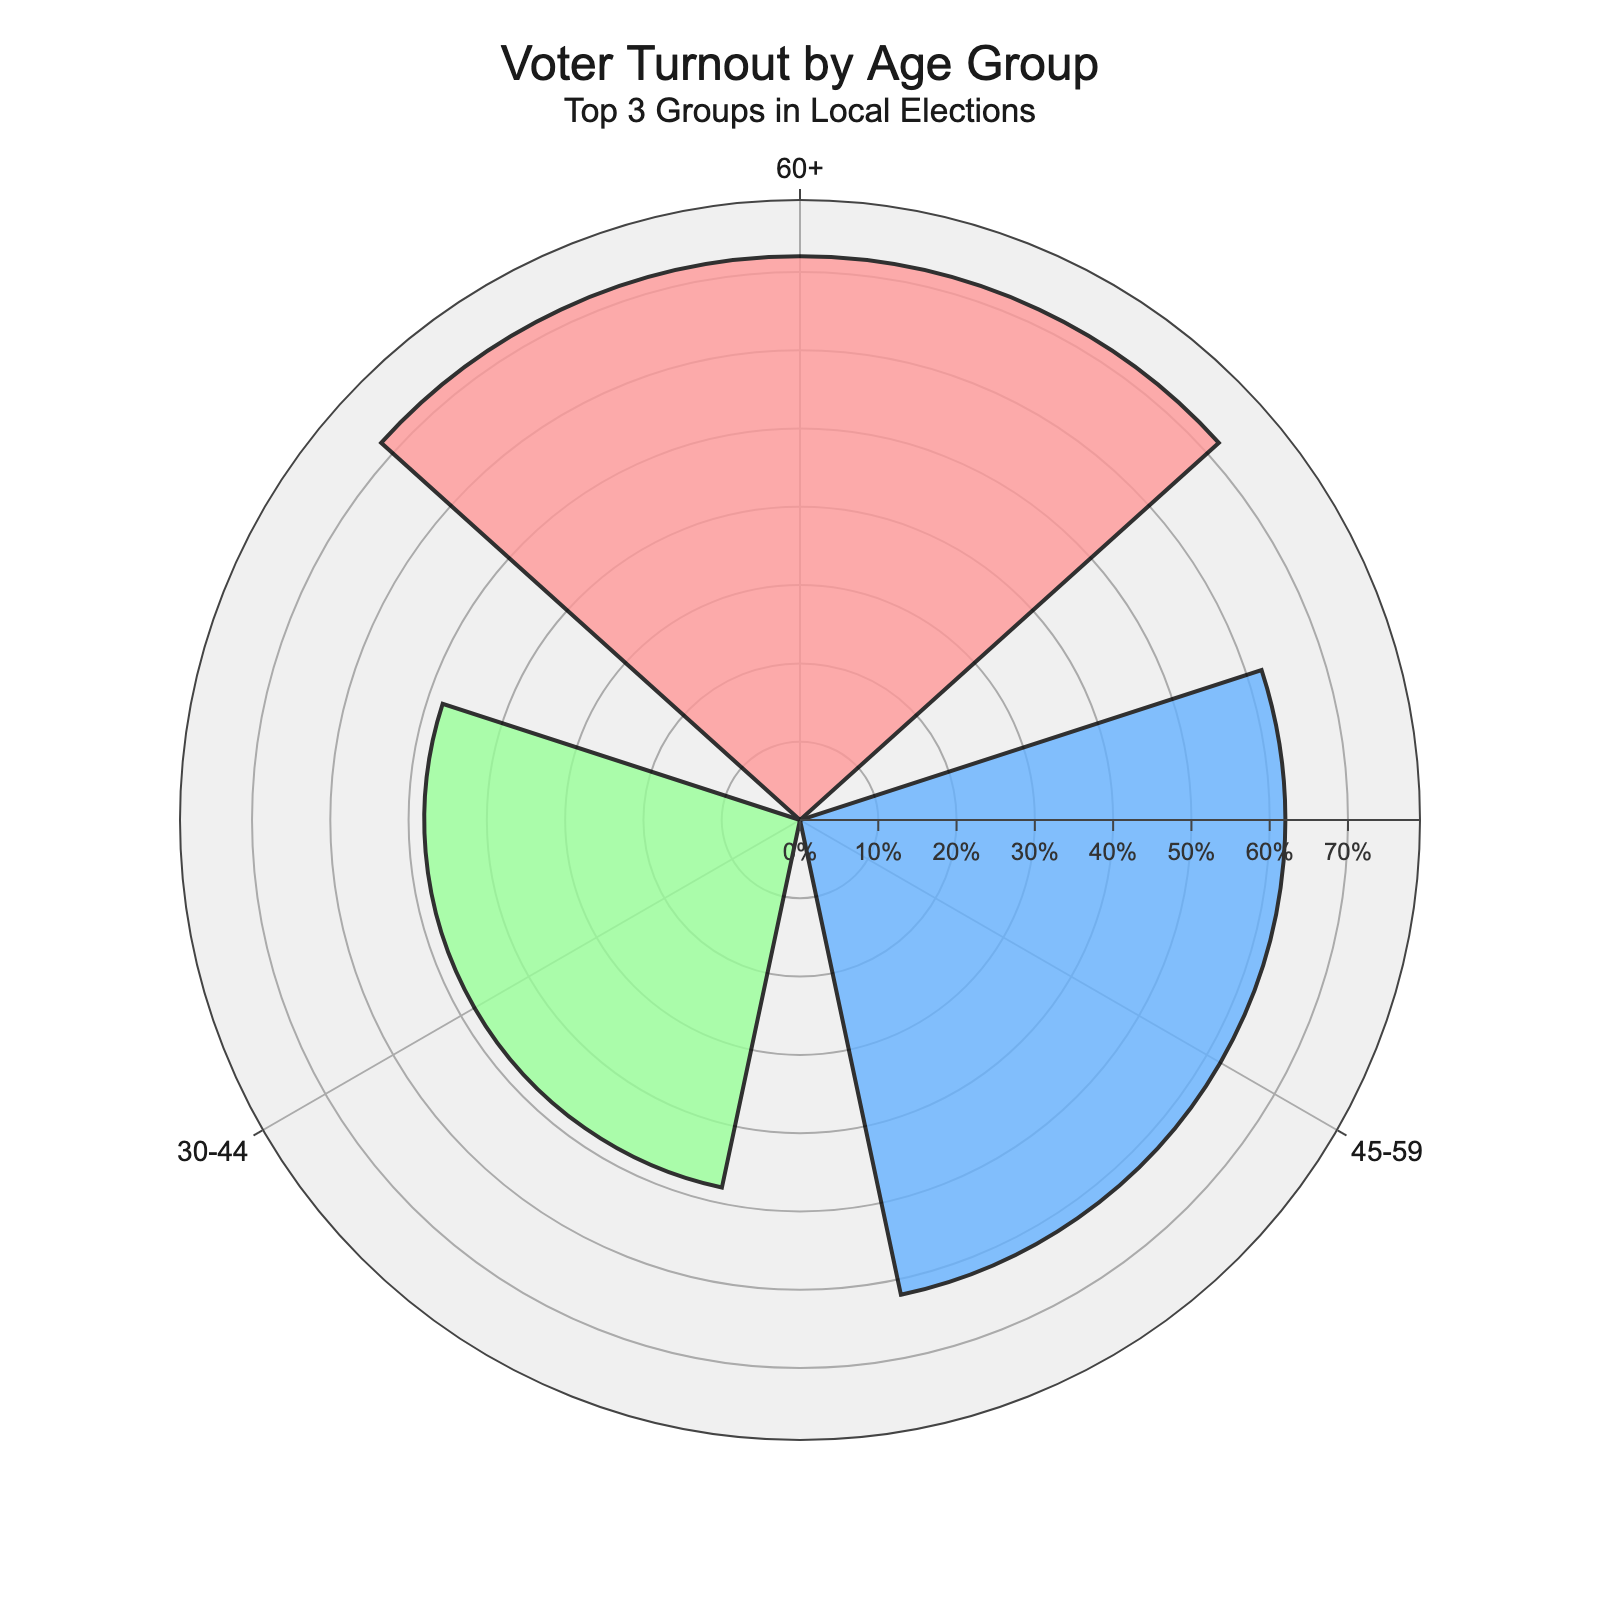what's the title of the chart? The title of the chart is shown at the top center and usually summarizes what the chart is about. In this case, it reads: "Voter Turnout by Age Group" with a subtitle "Top 3 Groups in Local Elections".
Answer: Voter Turnout by Age Group how many age groups are shown in the chart? The chart displays the top 3 age groups with the highest voter turnout percentages. The bars represent different age groups.
Answer: 3 which age group has the highest voter turnout? The age group with the highest voter turnout is represented by the longest bar on the rose chart. In this case, the longest bar is for the 60+ age group.
Answer: 60+ what is the voter turnout percentage for the 45-59 age group? By locating the bar labeled 45-59 in the chart, we can see the height of the bar corresponds to the voter turnout percentage. The value given for the 45-59 age group is 62%.
Answer: 62% what is the average voter turnout percentage of the top 3 age groups? To find the average, sum the voter turnout percentages of the 60+, 45-59, and 30-44 age groups and divide by the number of groups. (72 + 62 + 48) / 3 = 60.67%.
Answer: 60.67% how much higher is the voter turnout for the 60+ age group compared to the 30-44 age group? The difference in voter turnout between the 60+ age group and the 30-44 age group can be calculated by subtracting the voter turnout of the 30-44 group from that of the 60+ group. 72% - 48% = 24%.
Answer: 24% which age group has the second highest voter turnout? The second highest voter turnout is represented by the bar that is shorter than the highest but longer than the others. In this chart, it's the 45-59 age group.
Answer: 45-59 what colors are used to represent the voter turnout percentages? The rose chart uses three different colors to differentiate the age groups. The colors are red, blue, and green.
Answer: red, blue, and green 